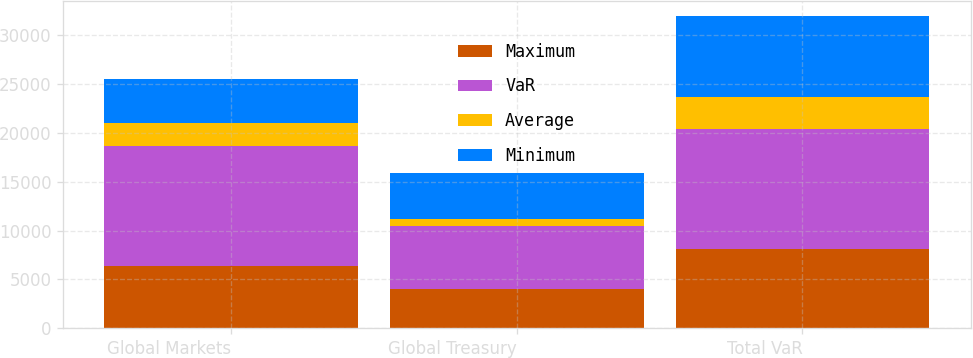<chart> <loc_0><loc_0><loc_500><loc_500><stacked_bar_chart><ecel><fcel>Global Markets<fcel>Global Treasury<fcel>Total VaR<nl><fcel>Maximum<fcel>6365<fcel>4027<fcel>8100<nl><fcel>VaR<fcel>12327<fcel>6467<fcel>12278<nl><fcel>Average<fcel>2273<fcel>683<fcel>3244<nl><fcel>Minimum<fcel>4566<fcel>4759<fcel>8281<nl></chart> 